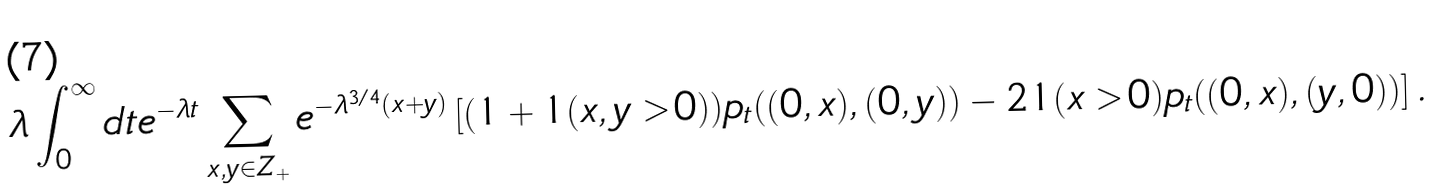<formula> <loc_0><loc_0><loc_500><loc_500>\lambda \int _ { 0 } ^ { \infty } d t e ^ { - \lambda t } \sum _ { x , y \in { Z } _ { + } } e ^ { - \lambda ^ { 3 / 4 } ( x + y ) } \left [ ( 1 + { 1 } ( x , y > 0 ) ) p _ { t } ( ( 0 , x ) , ( 0 , y ) ) - 2 { 1 } ( x > 0 ) p _ { t } ( ( 0 , x ) , ( y , 0 ) ) \right ] .</formula> 